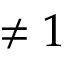Convert formula to latex. <formula><loc_0><loc_0><loc_500><loc_500>\neq 1</formula> 